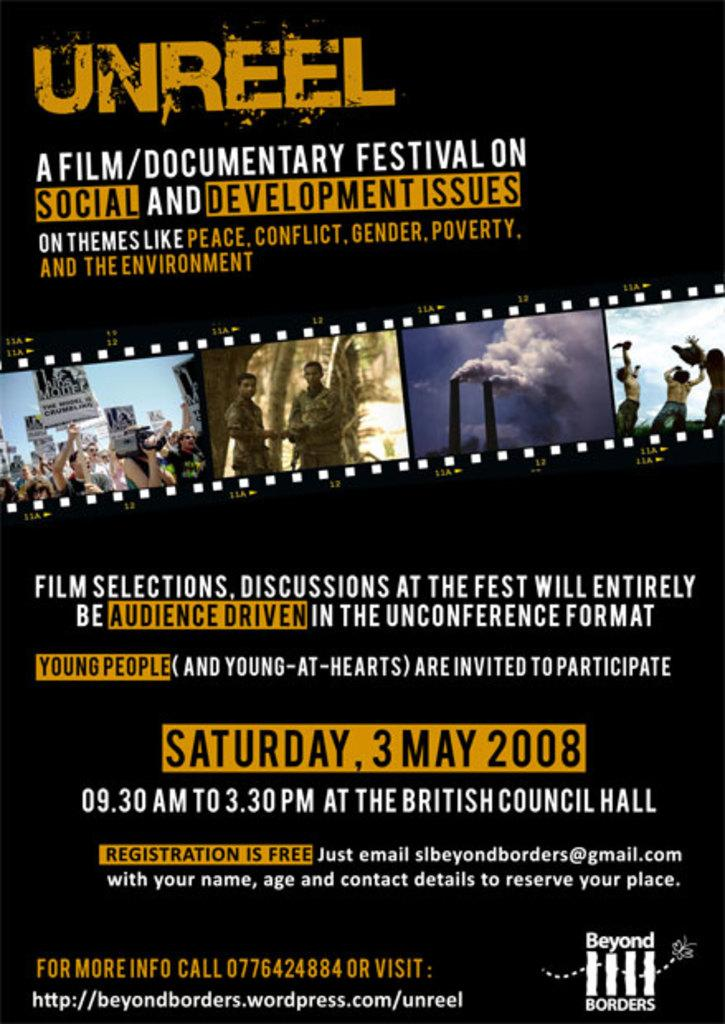<image>
Relay a brief, clear account of the picture shown. a movie poster for Unreel a film/documentary festival about social and development issues 